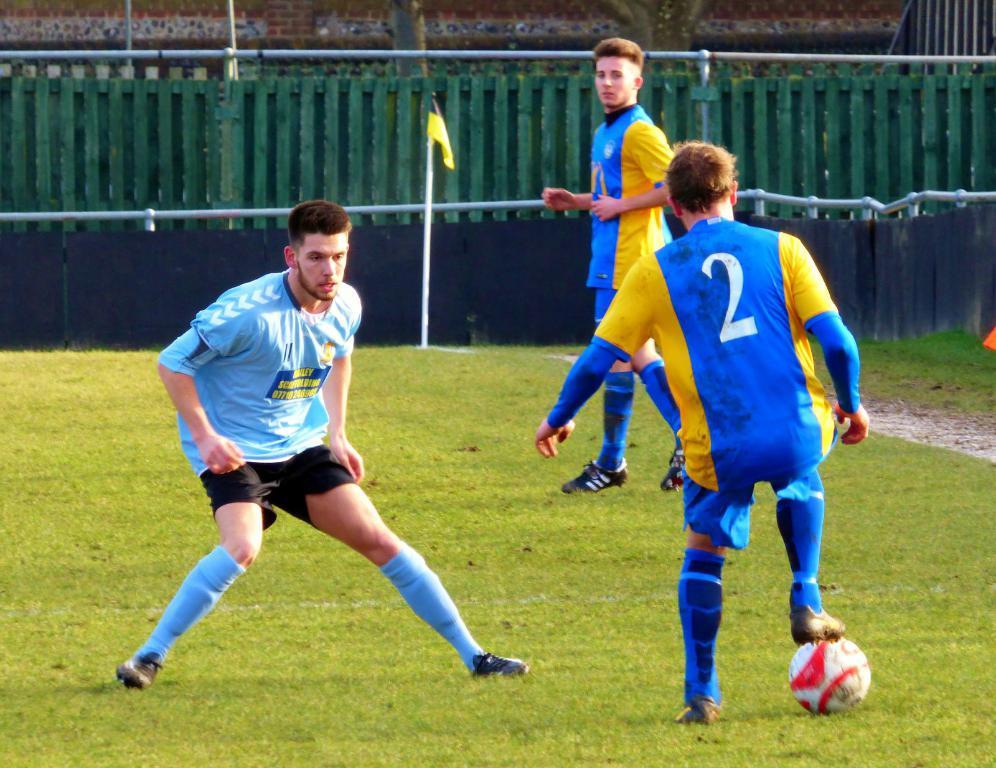What is the number on the blue and yellow jersey?
Provide a succinct answer. 2. 